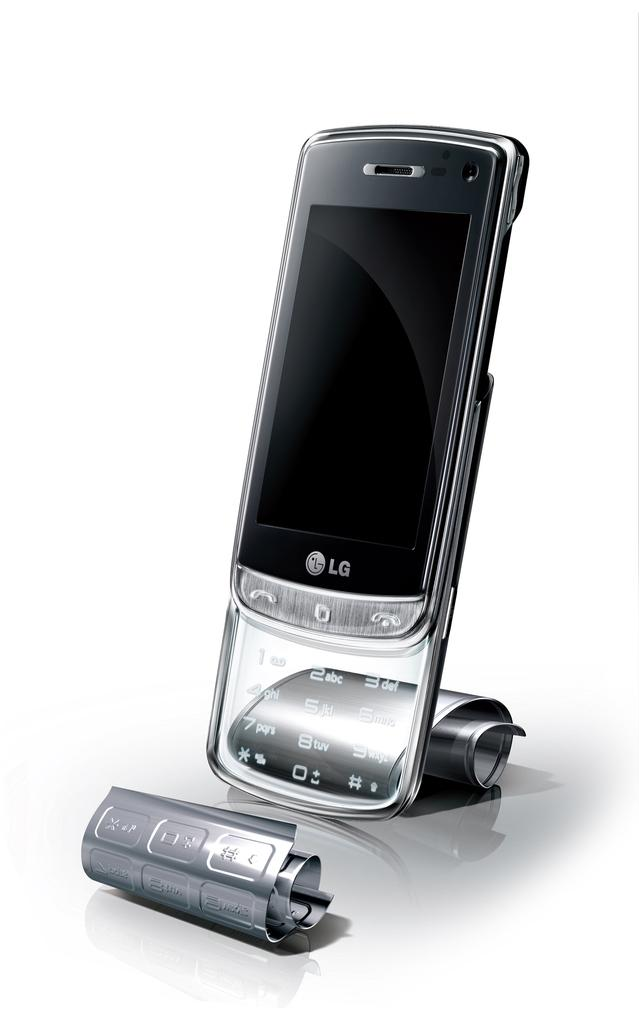<image>
Offer a succinct explanation of the picture presented. A silver LG cellphone with no display propped up vertically. 